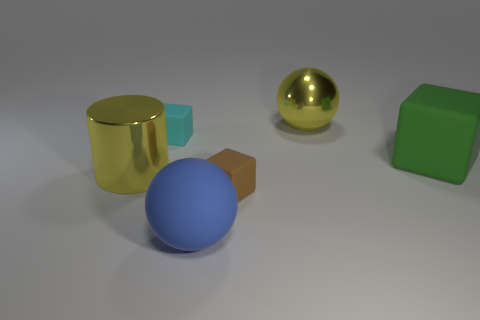Subtract all small matte blocks. How many blocks are left? 1 Add 3 small cyan rubber blocks. How many objects exist? 9 Subtract all blue cubes. Subtract all brown cylinders. How many cubes are left? 3 Subtract all cylinders. How many objects are left? 5 Subtract 0 purple cubes. How many objects are left? 6 Subtract all small balls. Subtract all brown matte things. How many objects are left? 5 Add 4 blue things. How many blue things are left? 5 Add 1 big balls. How many big balls exist? 3 